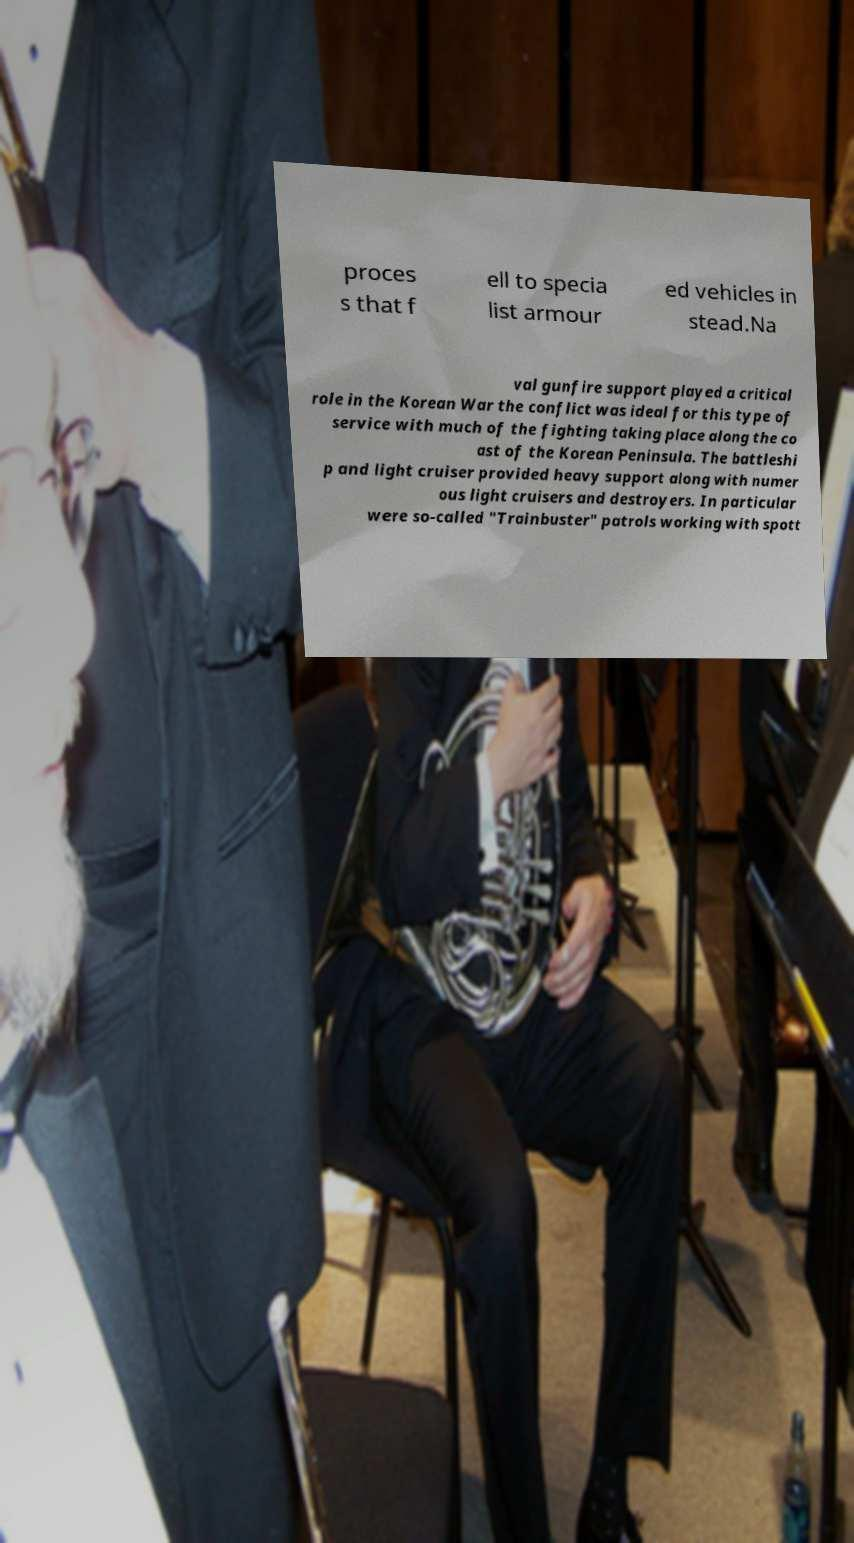Could you assist in decoding the text presented in this image and type it out clearly? proces s that f ell to specia list armour ed vehicles in stead.Na val gunfire support played a critical role in the Korean War the conflict was ideal for this type of service with much of the fighting taking place along the co ast of the Korean Peninsula. The battleshi p and light cruiser provided heavy support along with numer ous light cruisers and destroyers. In particular were so-called "Trainbuster" patrols working with spott 